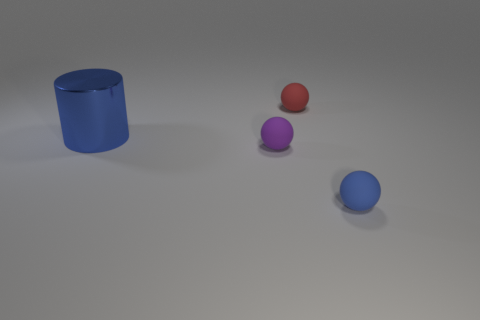Add 2 brown matte cubes. How many objects exist? 6 Subtract all cylinders. How many objects are left? 3 Subtract all purple objects. Subtract all metallic cylinders. How many objects are left? 2 Add 1 large blue objects. How many large blue objects are left? 2 Add 3 red matte objects. How many red matte objects exist? 4 Subtract 0 yellow cylinders. How many objects are left? 4 